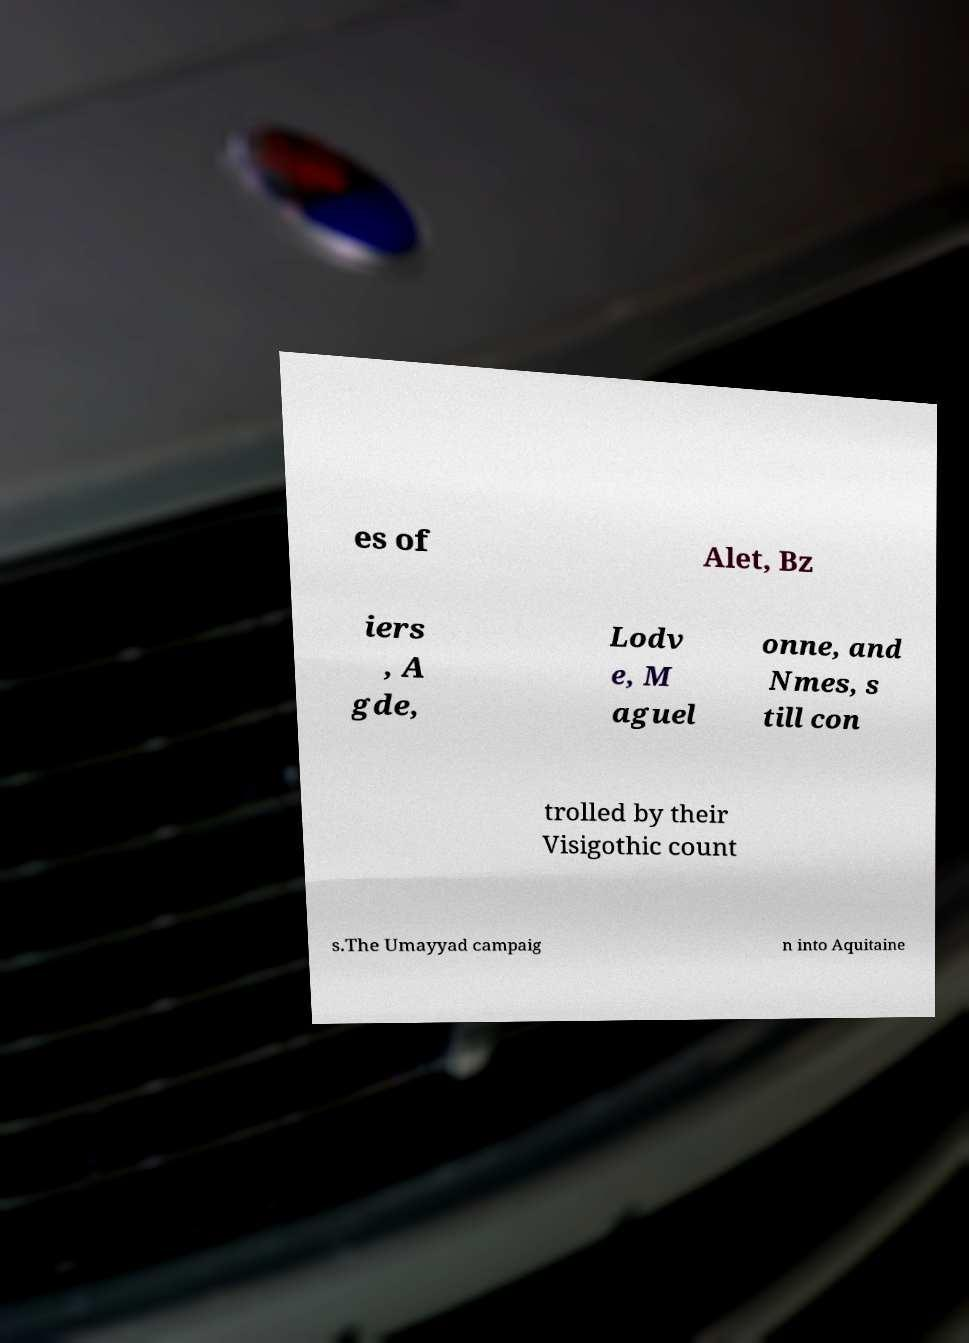Please read and relay the text visible in this image. What does it say? es of Alet, Bz iers , A gde, Lodv e, M aguel onne, and Nmes, s till con trolled by their Visigothic count s.The Umayyad campaig n into Aquitaine 